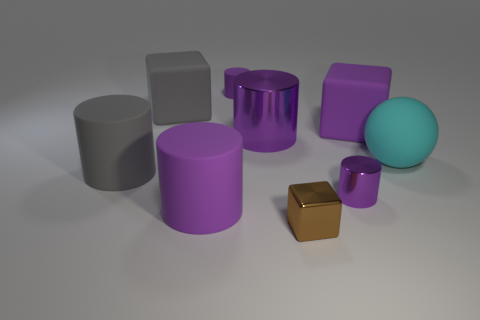Subtract all purple spheres. How many purple cylinders are left? 4 Subtract all gray cylinders. How many cylinders are left? 4 Subtract all tiny rubber cylinders. How many cylinders are left? 4 Subtract all red cylinders. Subtract all purple blocks. How many cylinders are left? 5 Subtract all cylinders. How many objects are left? 4 Subtract 0 green blocks. How many objects are left? 9 Subtract all brown metal things. Subtract all big shiny things. How many objects are left? 7 Add 3 cylinders. How many cylinders are left? 8 Add 2 big purple matte objects. How many big purple matte objects exist? 4 